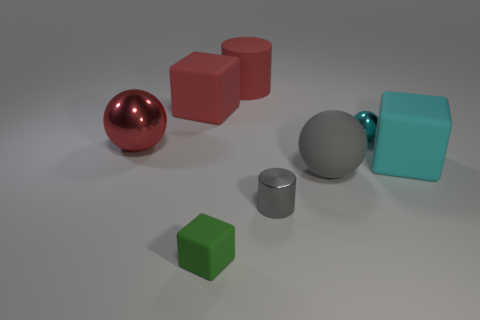What is the large block left of the large sphere in front of the red ball made of?
Provide a short and direct response. Rubber. What color is the metal object that is the same size as the gray matte ball?
Offer a terse response. Red. Are there any shiny things that have the same color as the large matte cylinder?
Your response must be concise. Yes. Are there any gray rubber objects?
Your answer should be very brief. Yes. Is the material of the gray thing left of the large gray matte sphere the same as the large gray object?
Make the answer very short. No. There is a rubber object that is the same color as the metallic cylinder; what size is it?
Your answer should be very brief. Large. What number of cyan spheres have the same size as the cyan block?
Make the answer very short. 0. Are there the same number of large rubber objects that are behind the red matte cylinder and tiny brown rubber objects?
Your answer should be very brief. Yes. How many objects are both to the left of the metal cylinder and in front of the big matte sphere?
Provide a short and direct response. 1. What size is the red thing that is made of the same material as the cyan ball?
Offer a terse response. Large. 